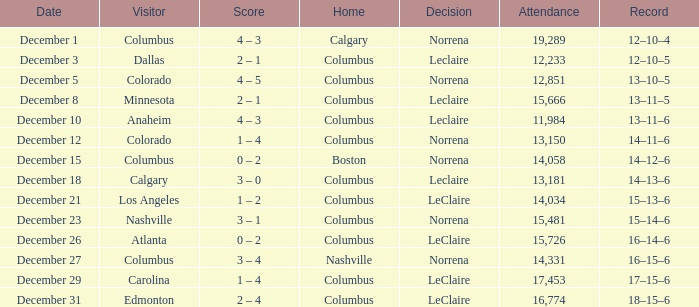What was the score when the record was 16 wins, 14 losses, and 6 ties? 0 – 2. 